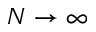<formula> <loc_0><loc_0><loc_500><loc_500>N \to \infty</formula> 